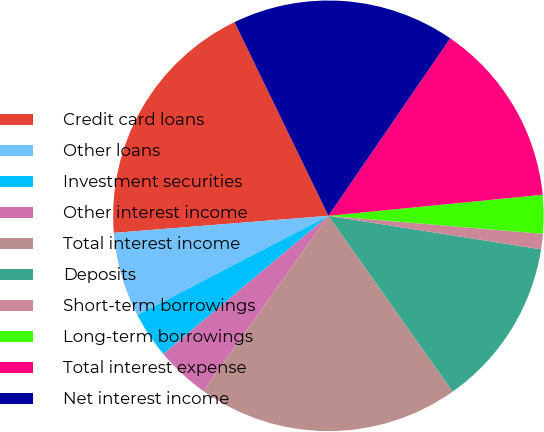<chart> <loc_0><loc_0><loc_500><loc_500><pie_chart><fcel>Credit card loans<fcel>Other loans<fcel>Investment securities<fcel>Other interest income<fcel>Total interest income<fcel>Deposits<fcel>Short-term borrowings<fcel>Long-term borrowings<fcel>Total interest expense<fcel>Net interest income<nl><fcel>19.08%<fcel>6.36%<fcel>3.47%<fcel>4.05%<fcel>19.65%<fcel>12.72%<fcel>1.16%<fcel>2.89%<fcel>13.87%<fcel>16.76%<nl></chart> 